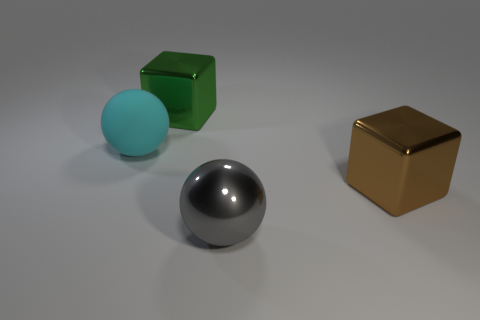Subtract all cyan spheres. How many spheres are left? 1 Add 4 big brown things. How many big brown things are left? 5 Add 2 tiny green cubes. How many tiny green cubes exist? 2 Add 1 rubber balls. How many objects exist? 5 Subtract 1 gray balls. How many objects are left? 3 Subtract 2 cubes. How many cubes are left? 0 Subtract all purple balls. Subtract all yellow cubes. How many balls are left? 2 Subtract all cyan cubes. How many yellow spheres are left? 0 Subtract all large metallic objects. Subtract all cyan objects. How many objects are left? 0 